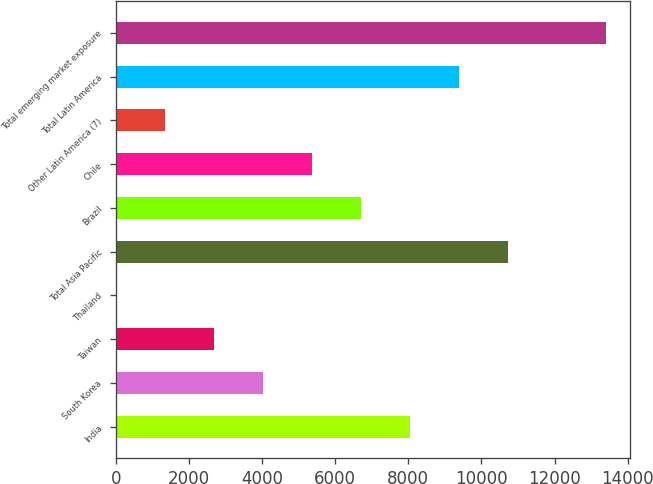Convert chart to OTSL. <chart><loc_0><loc_0><loc_500><loc_500><bar_chart><fcel>India<fcel>South Korea<fcel>Taiwan<fcel>Thailand<fcel>Total Asia Pacific<fcel>Brazil<fcel>Chile<fcel>Other Latin America (7)<fcel>Total Latin America<fcel>Total emerging market exposure<nl><fcel>8048.6<fcel>4034.3<fcel>2696.2<fcel>20<fcel>10724.8<fcel>6710.5<fcel>5372.4<fcel>1358.1<fcel>9386.7<fcel>13401<nl></chart> 